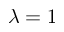<formula> <loc_0><loc_0><loc_500><loc_500>\lambda = 1</formula> 